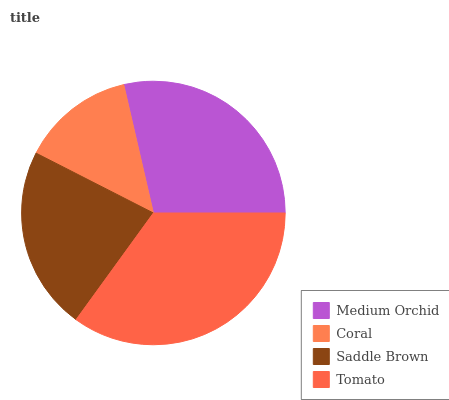Is Coral the minimum?
Answer yes or no. Yes. Is Tomato the maximum?
Answer yes or no. Yes. Is Saddle Brown the minimum?
Answer yes or no. No. Is Saddle Brown the maximum?
Answer yes or no. No. Is Saddle Brown greater than Coral?
Answer yes or no. Yes. Is Coral less than Saddle Brown?
Answer yes or no. Yes. Is Coral greater than Saddle Brown?
Answer yes or no. No. Is Saddle Brown less than Coral?
Answer yes or no. No. Is Medium Orchid the high median?
Answer yes or no. Yes. Is Saddle Brown the low median?
Answer yes or no. Yes. Is Coral the high median?
Answer yes or no. No. Is Coral the low median?
Answer yes or no. No. 